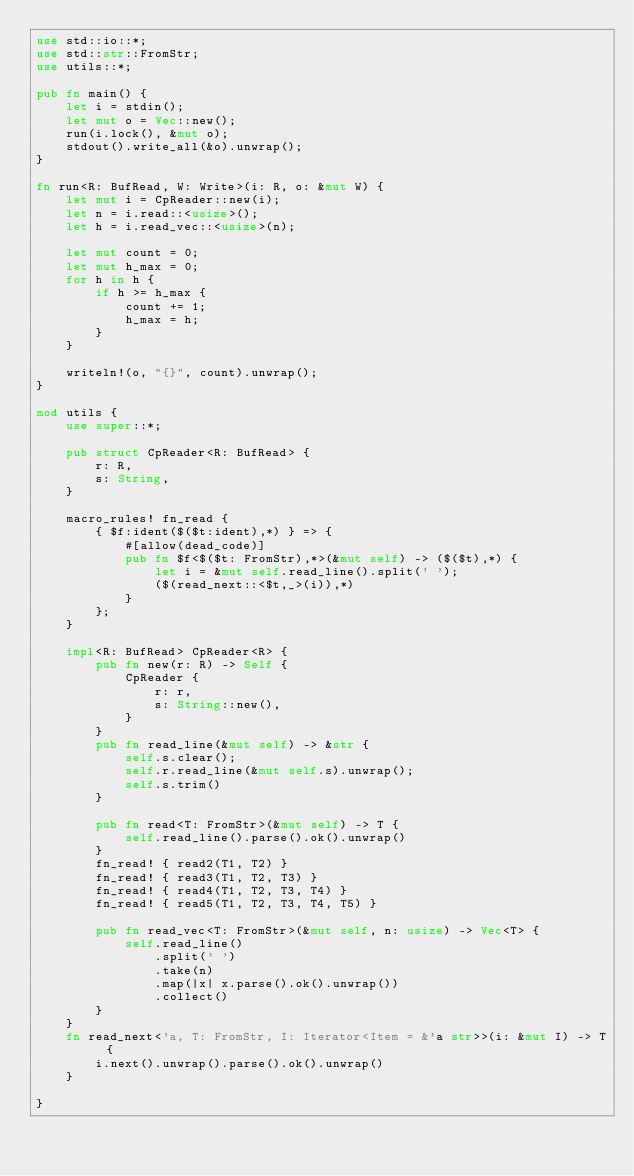Convert code to text. <code><loc_0><loc_0><loc_500><loc_500><_Rust_>use std::io::*;
use std::str::FromStr;
use utils::*;

pub fn main() {
    let i = stdin();
    let mut o = Vec::new();
    run(i.lock(), &mut o);
    stdout().write_all(&o).unwrap();
}

fn run<R: BufRead, W: Write>(i: R, o: &mut W) {
    let mut i = CpReader::new(i);
    let n = i.read::<usize>();
    let h = i.read_vec::<usize>(n);

    let mut count = 0;
    let mut h_max = 0;
    for h in h {
        if h >= h_max {
            count += 1;
            h_max = h;
        }
    }

    writeln!(o, "{}", count).unwrap();
}

mod utils {
    use super::*;

    pub struct CpReader<R: BufRead> {
        r: R,
        s: String,
    }

    macro_rules! fn_read {
        { $f:ident($($t:ident),*) } => {
            #[allow(dead_code)]
            pub fn $f<$($t: FromStr),*>(&mut self) -> ($($t),*) {
                let i = &mut self.read_line().split(' ');
                ($(read_next::<$t,_>(i)),*)
            }
        };
    }

    impl<R: BufRead> CpReader<R> {
        pub fn new(r: R) -> Self {
            CpReader {
                r: r,
                s: String::new(),
            }
        }
        pub fn read_line(&mut self) -> &str {
            self.s.clear();
            self.r.read_line(&mut self.s).unwrap();
            self.s.trim()
        }

        pub fn read<T: FromStr>(&mut self) -> T {
            self.read_line().parse().ok().unwrap()
        }
        fn_read! { read2(T1, T2) }
        fn_read! { read3(T1, T2, T3) }
        fn_read! { read4(T1, T2, T3, T4) }
        fn_read! { read5(T1, T2, T3, T4, T5) }

        pub fn read_vec<T: FromStr>(&mut self, n: usize) -> Vec<T> {
            self.read_line()
                .split(' ')
                .take(n)
                .map(|x| x.parse().ok().unwrap())
                .collect()
        }
    }
    fn read_next<'a, T: FromStr, I: Iterator<Item = &'a str>>(i: &mut I) -> T {
        i.next().unwrap().parse().ok().unwrap()
    }

}
</code> 